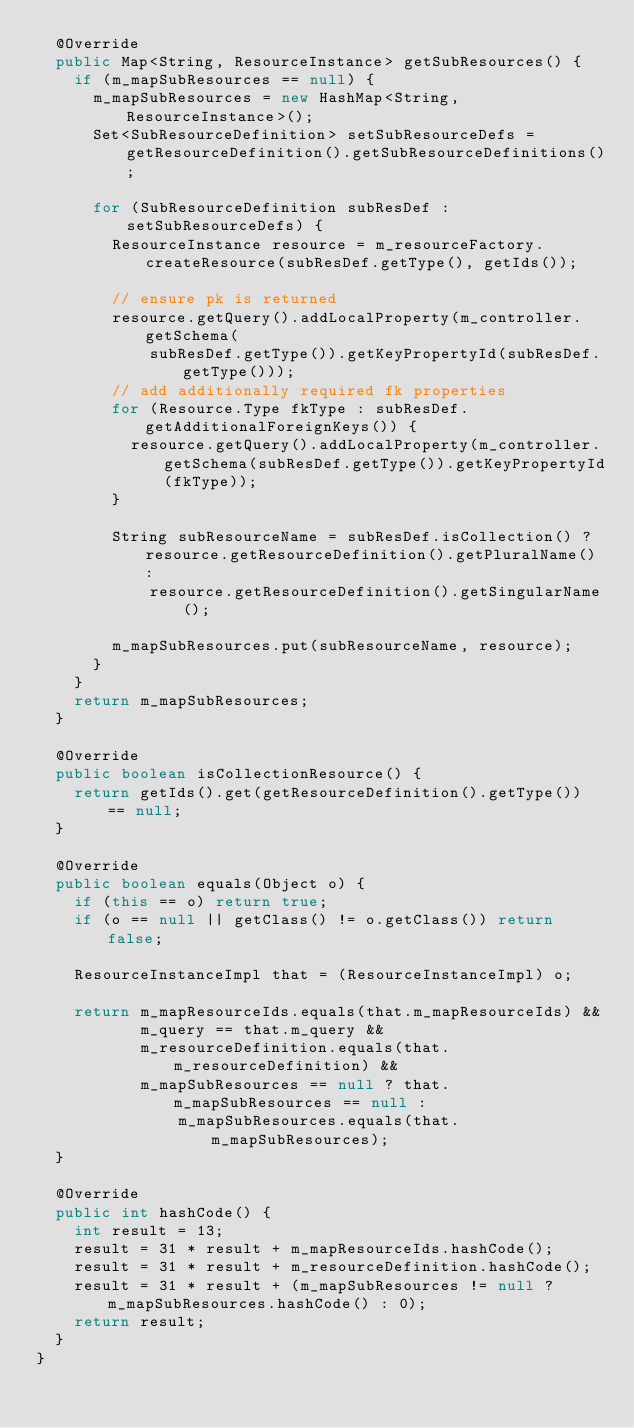Convert code to text. <code><loc_0><loc_0><loc_500><loc_500><_Java_>  @Override
  public Map<String, ResourceInstance> getSubResources() {
    if (m_mapSubResources == null) {
      m_mapSubResources = new HashMap<String, ResourceInstance>();
      Set<SubResourceDefinition> setSubResourceDefs = getResourceDefinition().getSubResourceDefinitions();

      for (SubResourceDefinition subResDef : setSubResourceDefs) {
        ResourceInstance resource = m_resourceFactory.createResource(subResDef.getType(), getIds());

        // ensure pk is returned
        resource.getQuery().addLocalProperty(m_controller.getSchema(
            subResDef.getType()).getKeyPropertyId(subResDef.getType()));
        // add additionally required fk properties
        for (Resource.Type fkType : subResDef.getAdditionalForeignKeys()) {
          resource.getQuery().addLocalProperty(m_controller.getSchema(subResDef.getType()).getKeyPropertyId(fkType));
        }

        String subResourceName = subResDef.isCollection() ? resource.getResourceDefinition().getPluralName() :
            resource.getResourceDefinition().getSingularName();

        m_mapSubResources.put(subResourceName, resource);
      }
    }
    return m_mapSubResources;
  }

  @Override
  public boolean isCollectionResource() {
    return getIds().get(getResourceDefinition().getType()) == null;
  }

  @Override
  public boolean equals(Object o) {
    if (this == o) return true;
    if (o == null || getClass() != o.getClass()) return false;

    ResourceInstanceImpl that = (ResourceInstanceImpl) o;

    return m_mapResourceIds.equals(that.m_mapResourceIds) &&
           m_query == that.m_query &&
           m_resourceDefinition.equals(that.m_resourceDefinition) &&
           m_mapSubResources == null ? that.m_mapSubResources == null :
               m_mapSubResources.equals(that.m_mapSubResources);
  }

  @Override
  public int hashCode() {
    int result = 13;
    result = 31 * result + m_mapResourceIds.hashCode();
    result = 31 * result + m_resourceDefinition.hashCode();
    result = 31 * result + (m_mapSubResources != null ? m_mapSubResources.hashCode() : 0);
    return result;
  }
}
</code> 